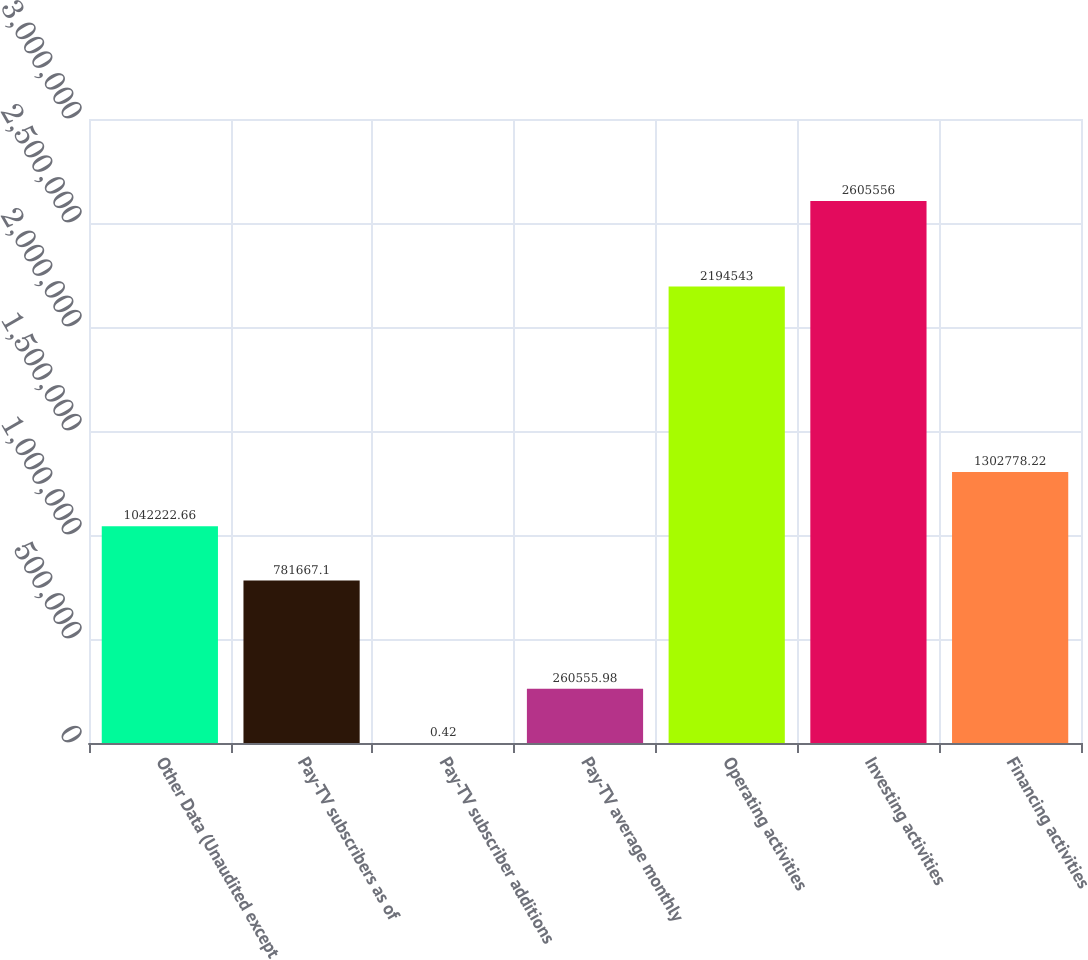Convert chart to OTSL. <chart><loc_0><loc_0><loc_500><loc_500><bar_chart><fcel>Other Data (Unaudited except<fcel>Pay-TV subscribers as of<fcel>Pay-TV subscriber additions<fcel>Pay-TV average monthly<fcel>Operating activities<fcel>Investing activities<fcel>Financing activities<nl><fcel>1.04222e+06<fcel>781667<fcel>0.42<fcel>260556<fcel>2.19454e+06<fcel>2.60556e+06<fcel>1.30278e+06<nl></chart> 